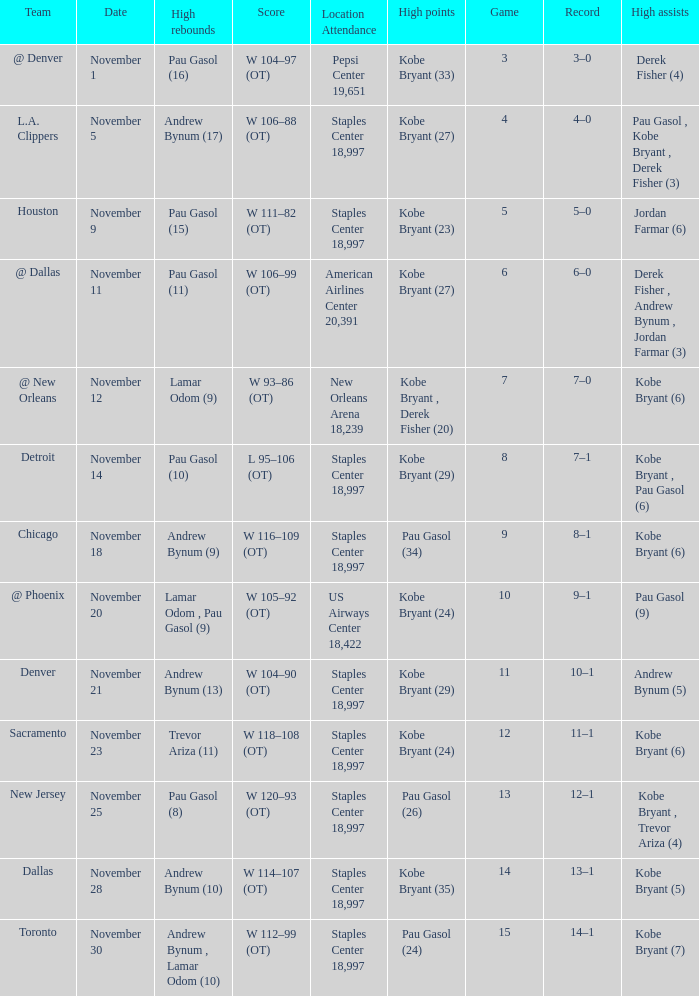What is High Assists, when High Points is "Kobe Bryant (27)", and when High Rebounds is "Pau Gasol (11)"? Derek Fisher , Andrew Bynum , Jordan Farmar (3). 